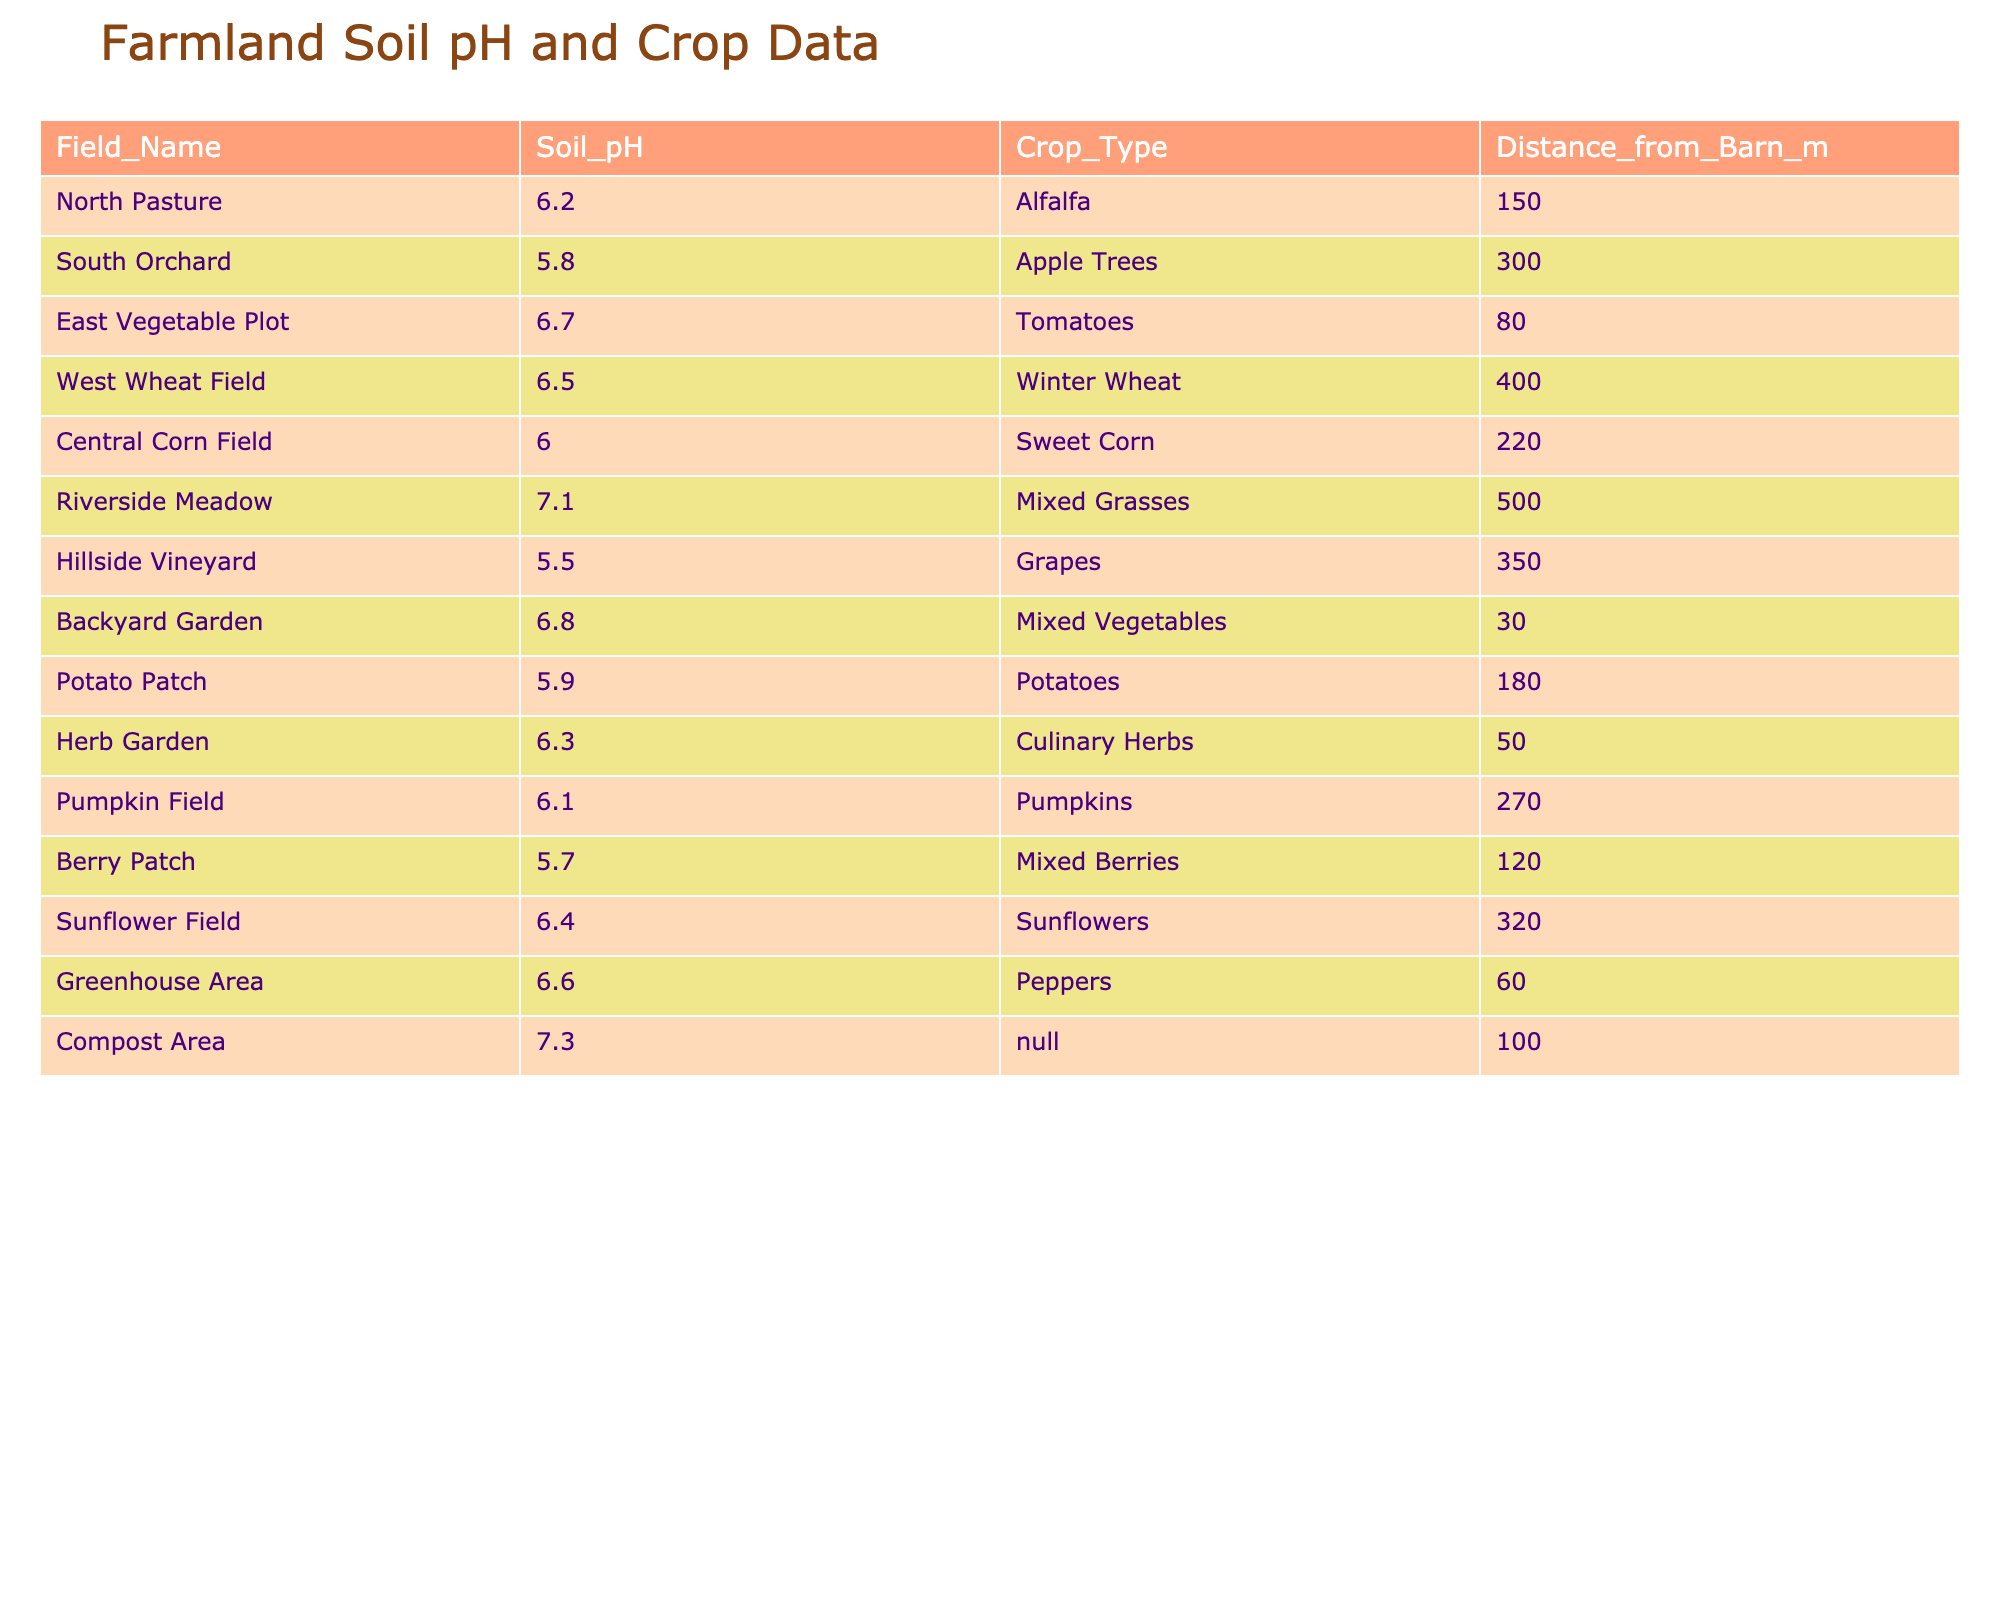What is the pH level of the Hillside Vineyard? The table lists the pH level for each field, and for the Hillside Vineyard, it is 5.5.
Answer: 5.5 Which crop is grown in the East Vegetable Plot? The table indicates that the crop in the East Vegetable Plot is Tomatoes.
Answer: Tomatoes What is the average soil pH level of the North Pasture and South Orchard? The pH levels are 6.2 for North Pasture and 5.8 for South Orchard. To find the average, (6.2 + 5.8) / 2 = 6.0.
Answer: 6.0 Is the pH level in the Backyard Garden above 6.5? The Backyard Garden has a pH level of 6.8, which is above 6.5.
Answer: Yes Which field is the farthest from the barn, and what is its soil pH level? Riverside Meadow is the farthest field from the barn at 500 meters, with a pH level of 7.1.
Answer: Riverside Meadow, 7.1 How many fields have a soil pH level below 6.0? The fields below 6.0 are the South Orchard (5.8), Hillside Vineyard (5.5), and Berry Patch (5.7), totaling three fields.
Answer: 3 What is the difference in pH level between the Compost Area and the Hillside Vineyard? The pH level in the Compost Area is 7.3, and in the Hillside Vineyard is 5.5. The difference is 7.3 - 5.5 = 1.8.
Answer: 1.8 Which crop type is associated with the field that has the highest pH level? The highest pH level is found in the Compost Area (7.3), which has no specified crop type (N/A).
Answer: N/A What is the total distance from the barn for the fields growing fruits (like Apple Trees and Grapes)? The distance for the South Orchard (Apple Trees) is 300 meters and for the Hillside Vineyard (Grapes) is 350 meters. Thus, the total is 300 + 350 = 650 meters.
Answer: 650 Is there a correlation between distance from the barn and soil pH level? To determine correlation, we would look for a trend in the data. The pH levels do not show a consistent upward or downward trend as distance increases. Therefore, there is no correlation.
Answer: No 